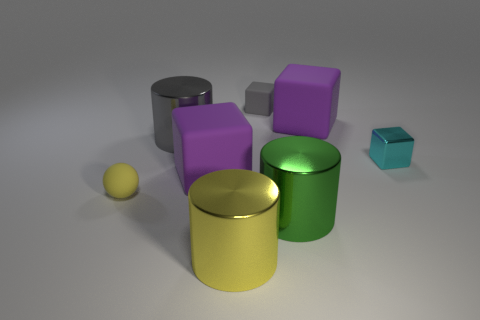Add 1 tiny cyan cubes. How many objects exist? 9 Subtract all balls. How many objects are left? 7 Subtract all small things. Subtract all purple metal cylinders. How many objects are left? 5 Add 1 small objects. How many small objects are left? 4 Add 5 small matte cubes. How many small matte cubes exist? 6 Subtract 0 red blocks. How many objects are left? 8 